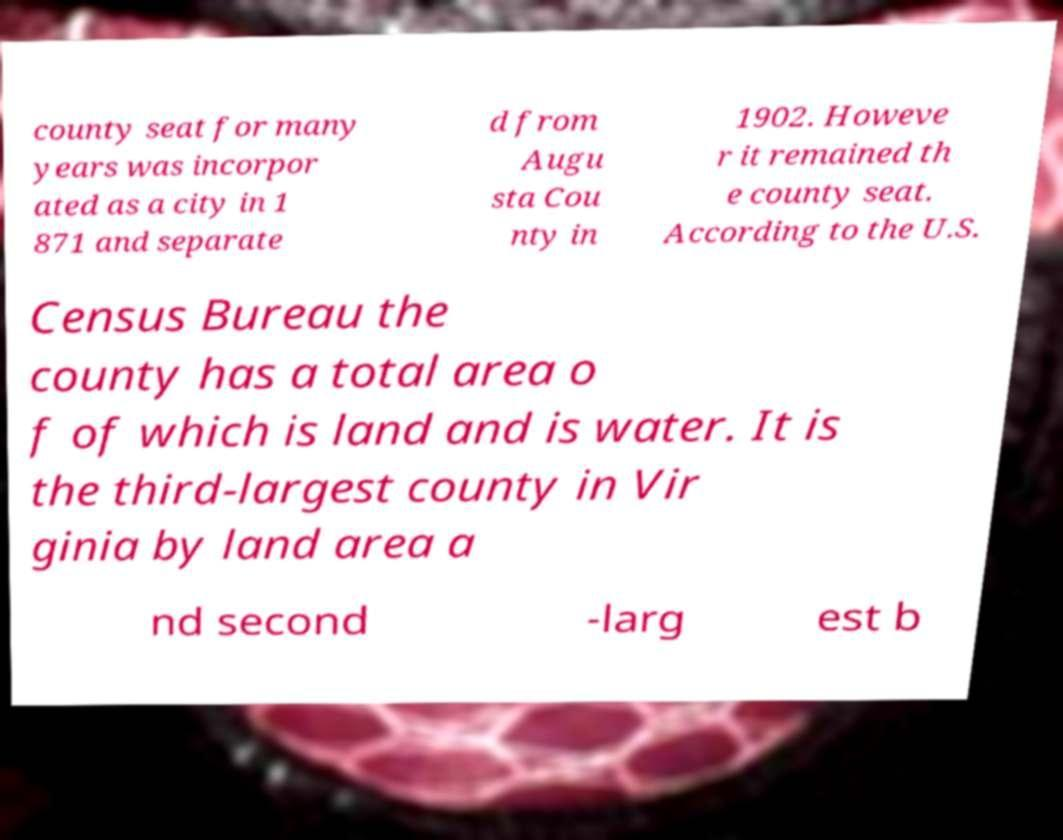Please read and relay the text visible in this image. What does it say? county seat for many years was incorpor ated as a city in 1 871 and separate d from Augu sta Cou nty in 1902. Howeve r it remained th e county seat. According to the U.S. Census Bureau the county has a total area o f of which is land and is water. It is the third-largest county in Vir ginia by land area a nd second -larg est b 